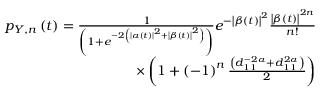Convert formula to latex. <formula><loc_0><loc_0><loc_500><loc_500>\begin{array} { r } { p _ { Y , n } \left ( t \right ) = \frac { 1 } { \left ( 1 + e ^ { - 2 \left ( \left | \alpha \left ( t \right ) \right | ^ { 2 } + \left | \beta \left ( t \right ) \right | ^ { 2 } \right ) } \right ) } e ^ { - \left | \beta \left ( t \right ) \right | ^ { 2 } } \frac { \left | \beta \left ( t \right ) \right | ^ { 2 n } } { n ! } } \\ { \times \left ( 1 + \left ( - 1 \right ) ^ { n } \frac { \left ( d _ { 1 1 } ^ { - 2 \alpha } + d _ { 1 1 } ^ { 2 \alpha } \right ) } { 2 } \right ) } \end{array}</formula> 